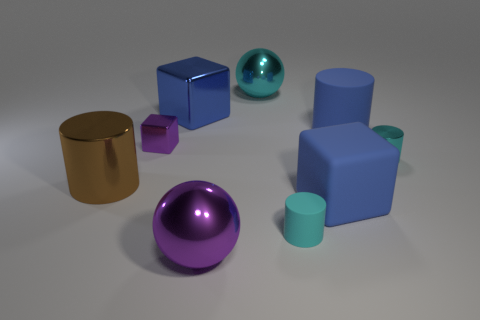Add 1 tiny purple metallic objects. How many objects exist? 10 Subtract all blocks. How many objects are left? 6 Subtract all cyan matte spheres. Subtract all big matte cubes. How many objects are left? 8 Add 2 large blue shiny blocks. How many large blue shiny blocks are left? 3 Add 5 tiny brown things. How many tiny brown things exist? 5 Subtract 0 purple cylinders. How many objects are left? 9 